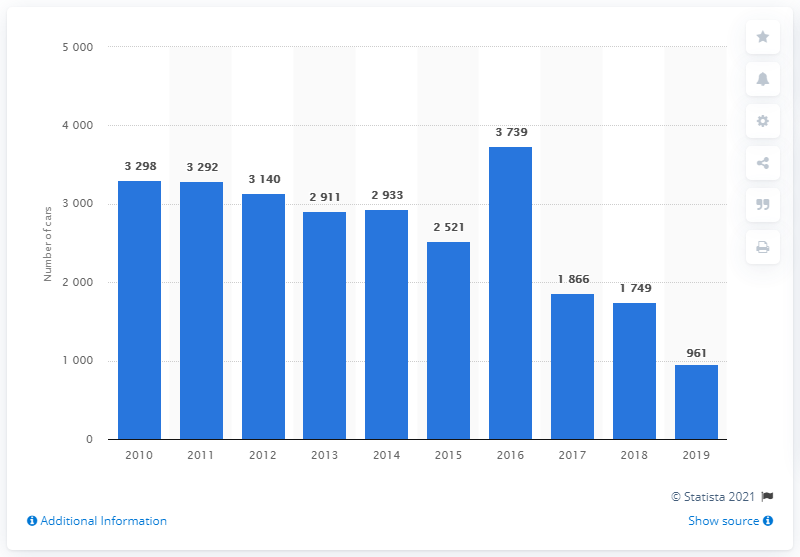List a handful of essential elements in this visual. In 2019, a total of 961 Honda cars were sold in Finland. 